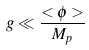Convert formula to latex. <formula><loc_0><loc_0><loc_500><loc_500>g \ll \frac { < \phi > } { M _ { p } }</formula> 